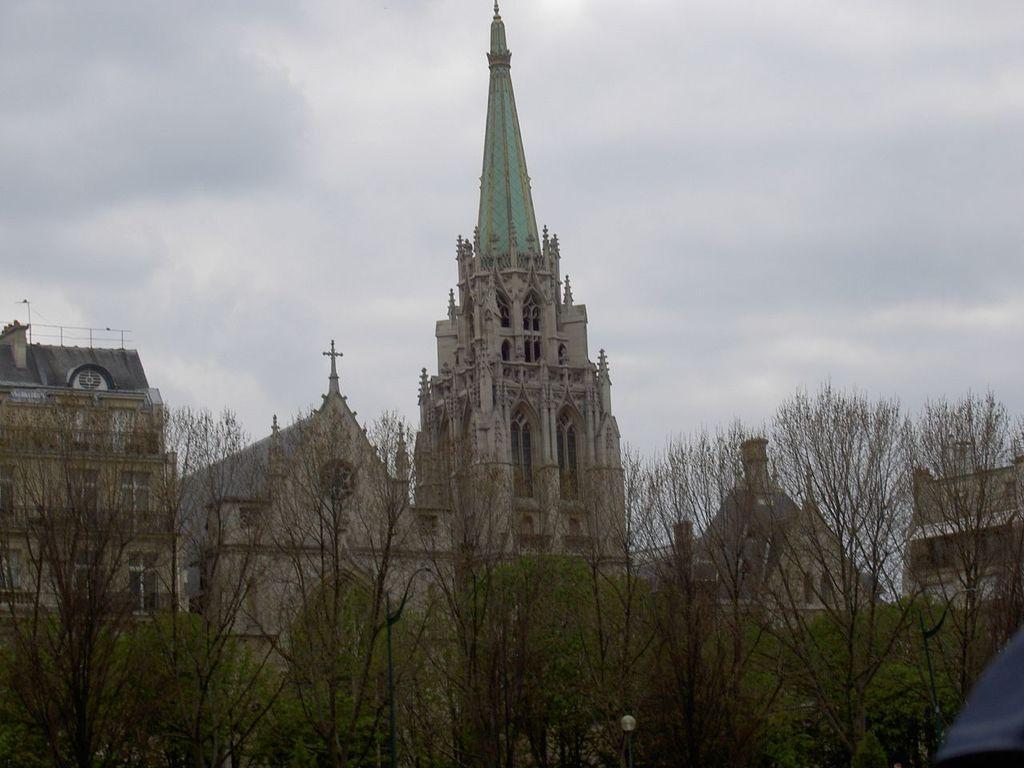Can you describe this image briefly? In this image I can see light pole, trees, buildings and cloudy sky. 